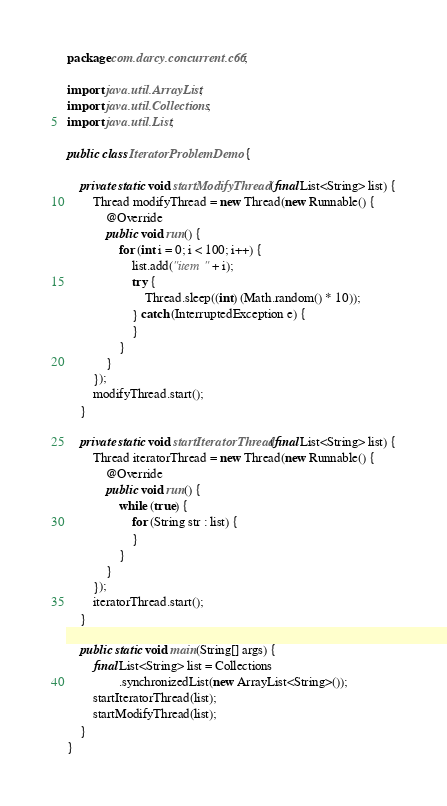<code> <loc_0><loc_0><loc_500><loc_500><_Java_>package com.darcy.concurrent.c66;

import java.util.ArrayList;
import java.util.Collections;
import java.util.List;

public class IteratorProblemDemo {

    private static void startModifyThread(final List<String> list) {
        Thread modifyThread = new Thread(new Runnable() {
            @Override
            public void run() {
                for (int i = 0; i < 100; i++) {
                    list.add("item " + i);
                    try {
                        Thread.sleep((int) (Math.random() * 10));
                    } catch (InterruptedException e) {
                    }
                }
            }
        });
        modifyThread.start();
    }

    private static void startIteratorThread(final List<String> list) {
        Thread iteratorThread = new Thread(new Runnable() {
            @Override
            public void run() {
                while (true) {
                    for (String str : list) {
                    }
                }
            }
        });
        iteratorThread.start();
    }

    public static void main(String[] args) {
        final List<String> list = Collections
                .synchronizedList(new ArrayList<String>());
        startIteratorThread(list);
        startModifyThread(list);
    }
}
</code> 